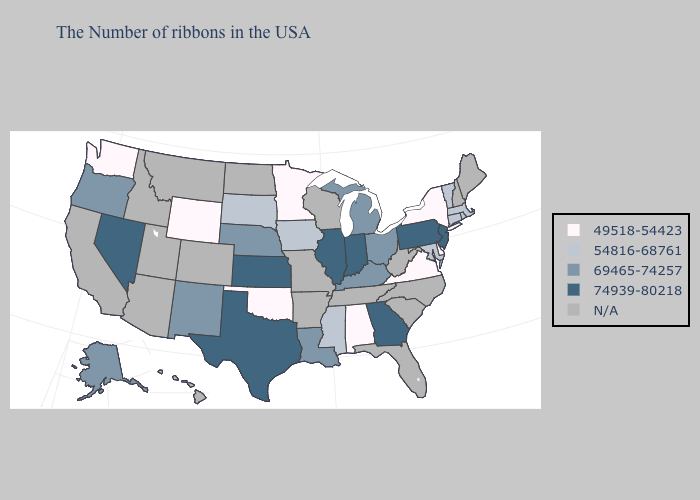What is the value of Rhode Island?
Give a very brief answer. 54816-68761. Does Texas have the highest value in the USA?
Answer briefly. Yes. Does Wyoming have the highest value in the USA?
Concise answer only. No. What is the lowest value in states that border Louisiana?
Write a very short answer. 54816-68761. Is the legend a continuous bar?
Quick response, please. No. What is the highest value in the USA?
Write a very short answer. 74939-80218. Which states hav the highest value in the South?
Keep it brief. Georgia, Texas. What is the lowest value in states that border Delaware?
Short answer required. 54816-68761. Which states have the lowest value in the USA?
Keep it brief. New York, Delaware, Virginia, Alabama, Minnesota, Oklahoma, Wyoming, Washington. Name the states that have a value in the range 49518-54423?
Give a very brief answer. New York, Delaware, Virginia, Alabama, Minnesota, Oklahoma, Wyoming, Washington. Which states have the lowest value in the USA?
Answer briefly. New York, Delaware, Virginia, Alabama, Minnesota, Oklahoma, Wyoming, Washington. What is the value of Mississippi?
Answer briefly. 54816-68761. Among the states that border California , does Oregon have the highest value?
Write a very short answer. No. What is the value of Michigan?
Quick response, please. 69465-74257. 